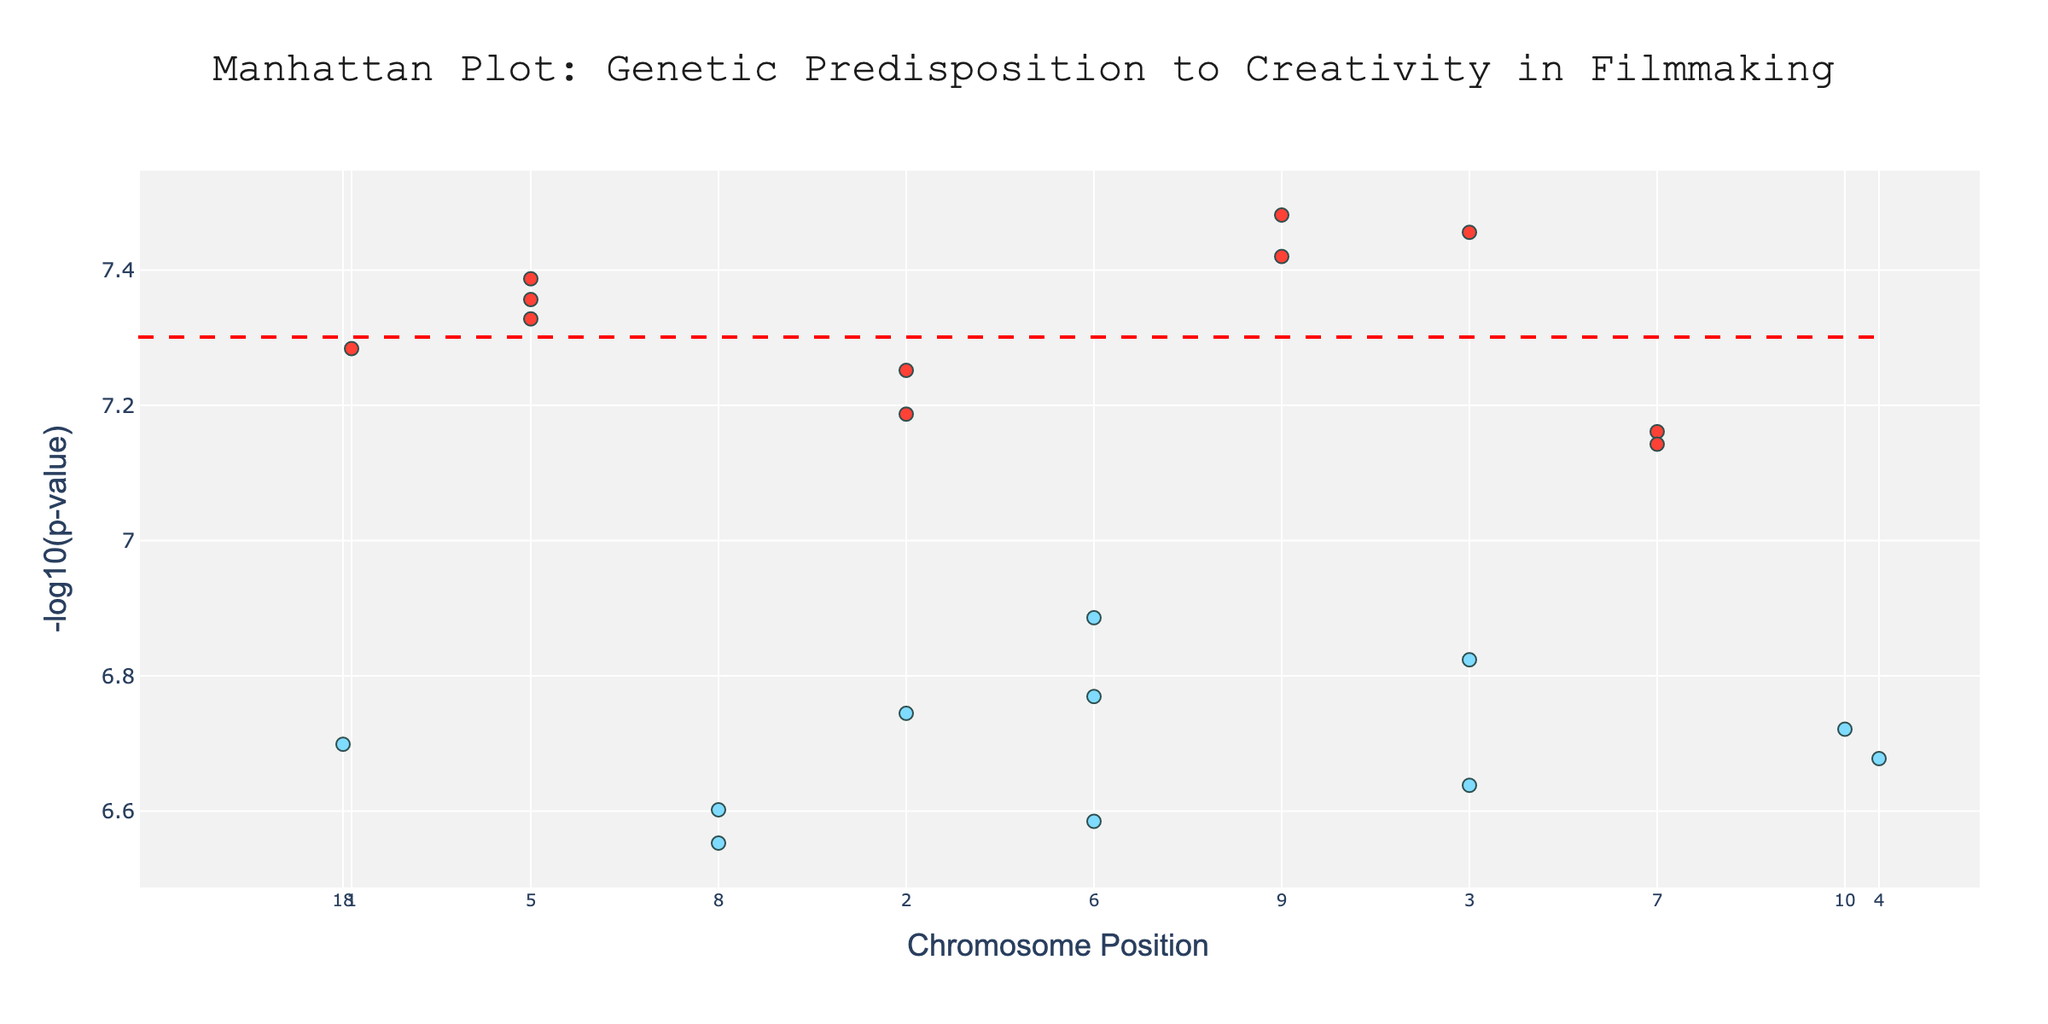What's the title of the plot? The title is displayed at the top center of the plot. It states "Manhattan Plot: Genetic Predisposition to Creativity in Filmmaking"
Answer: Manhattan Plot: Genetic Predisposition to Creativity in Filmmaking What does the y-axis represent? The y-axis title indicates that it represents "-log10(p-value)"
Answer: -log10(p-value) How many data points are represented as significant (highlighted)? Data points are shown in two colors. Red indicates significant points. Count the number of red points
Answer: 11 Which chromosome has the highest -log10(p-value) value? The highest point on the y-axis is the highest -log10(p-value). Identify the corresponding chromosome position and its label on the x-axis
Answer: Chromosome 17 What is the significance threshold line set at in terms of -log10(p-value)? The significance line is drawn horizontally. Its value is given by -log10(5e-8). Calculate this value
Answer: 7.3 Among the significant genes, which one has the lowest p-value? Significant genes are in red. Lowest p-value corresponds to the highest -log10(p-value). Identify the red point with the highest y-value and its corresponding gene on hover text
Answer: DISC1 Which has a higher -log10(p-value), FOXP2 or DRD4? Locate the positions of FOXP2 and DRD4 on the plot, both of which are significant. Evaluate the y-values for each and compare
Answer: DRD4 How many genes located on chromosome 15 are shown in the plot? Check on the x-axis for points corresponding to chromosome 15. Count these points
Answer: 1 What's the average -log10(p-value) of the significant genes? Calculate the -log10(p-value) of the significant genes and take the average. These values are for FOXP2, COMT, SLC6A3, CHRM2, GRIN2B, DRD4, HTR2A, GRIK4, DISC1, NCAN, and DTNBP1. Sum these and divide by 11
Answer: 7.727 